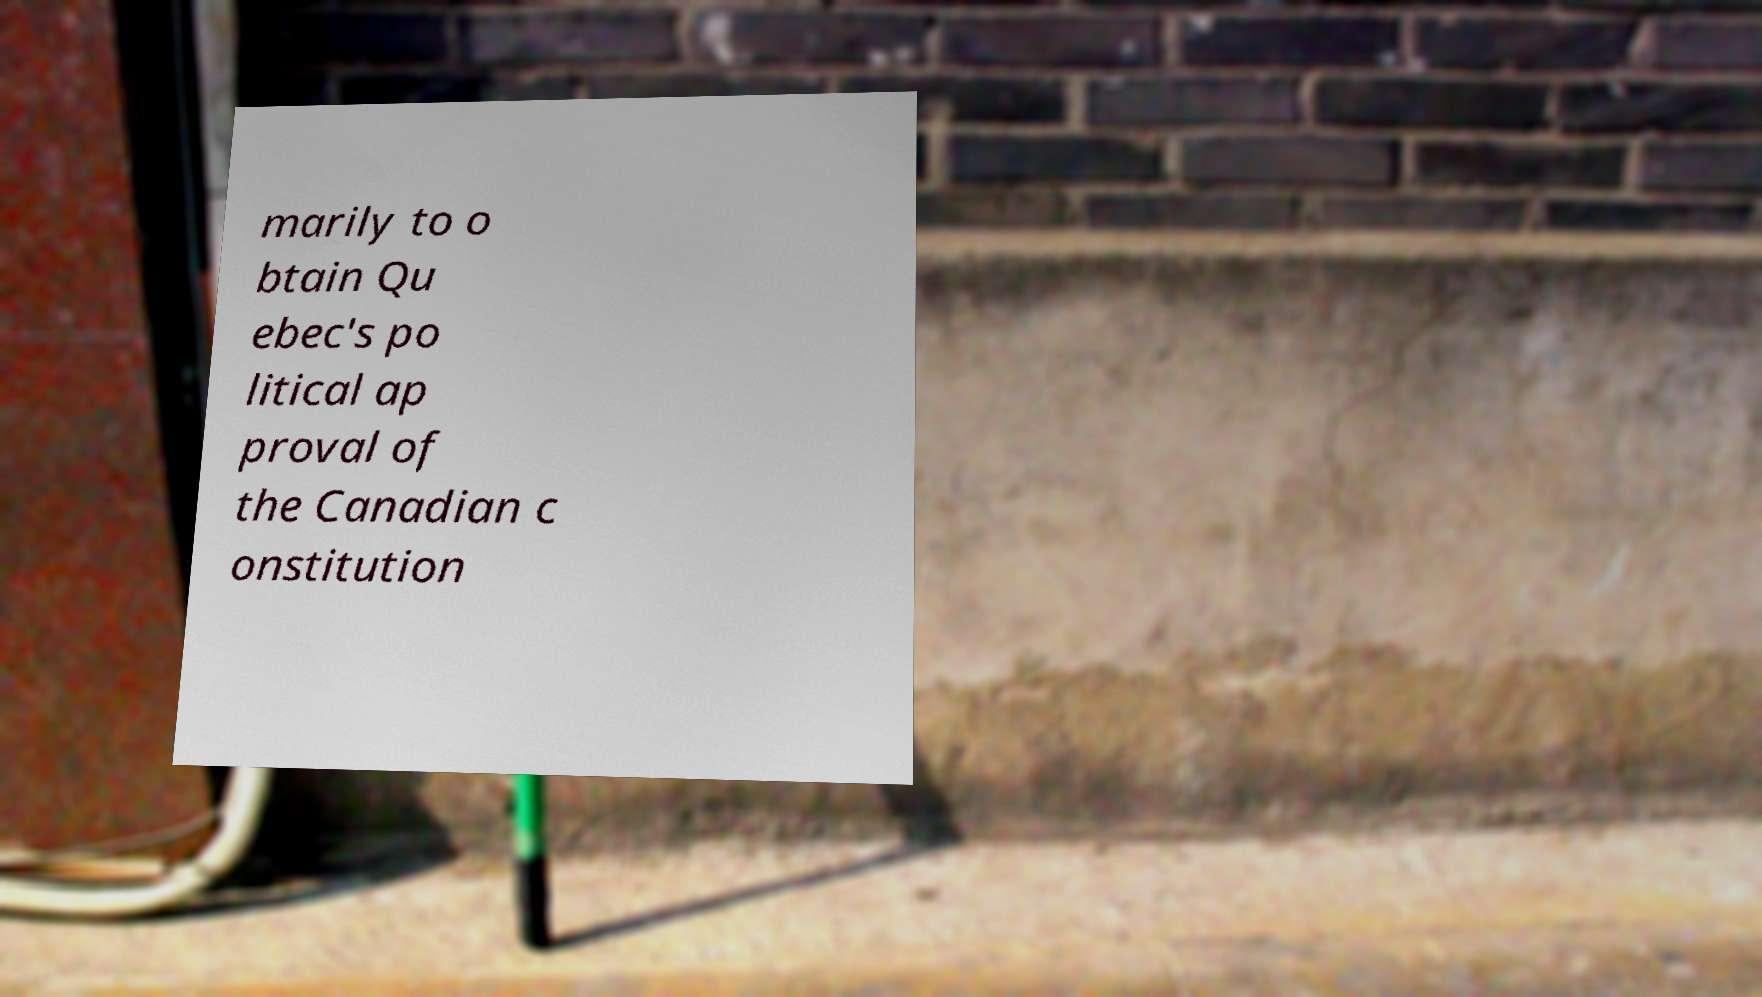There's text embedded in this image that I need extracted. Can you transcribe it verbatim? marily to o btain Qu ebec's po litical ap proval of the Canadian c onstitution 